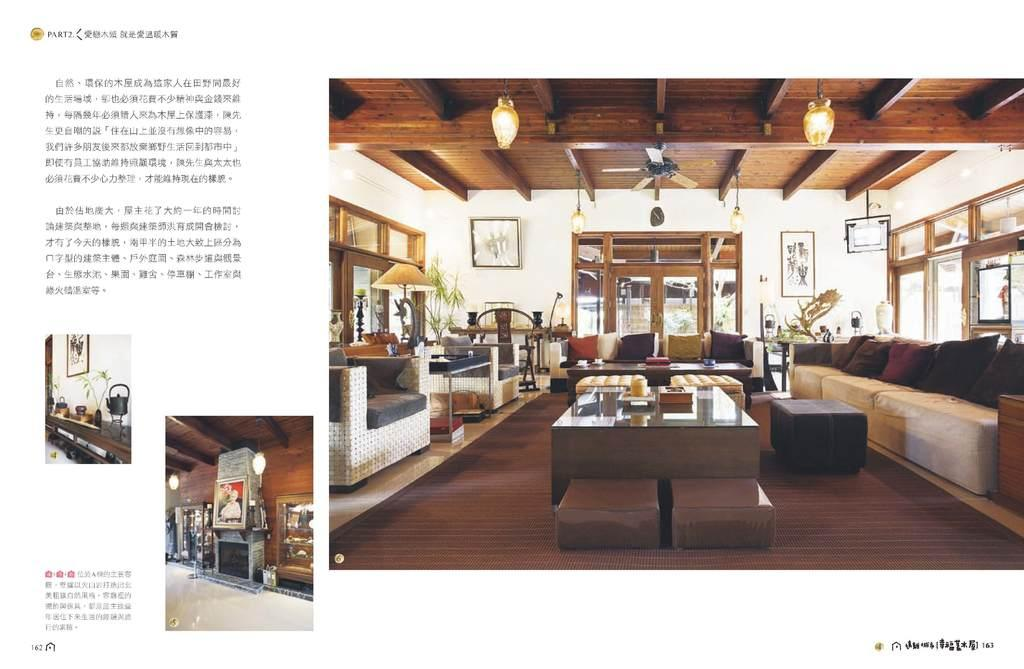What type of furniture is present in the image? There is a couch in the image. What can be seen on the couch? There is a pillow in the image. What other piece of furniture is in the image? There is a table in the image. What is the purpose of the lamp in the image? The lamp provides light in the image. What is hanging on the wall in the image? There is a frame in the image. What type of wine is being served on the table in the image? There is no wine present in the image; it only features a couch, pillow, table, lamp, and frame. 